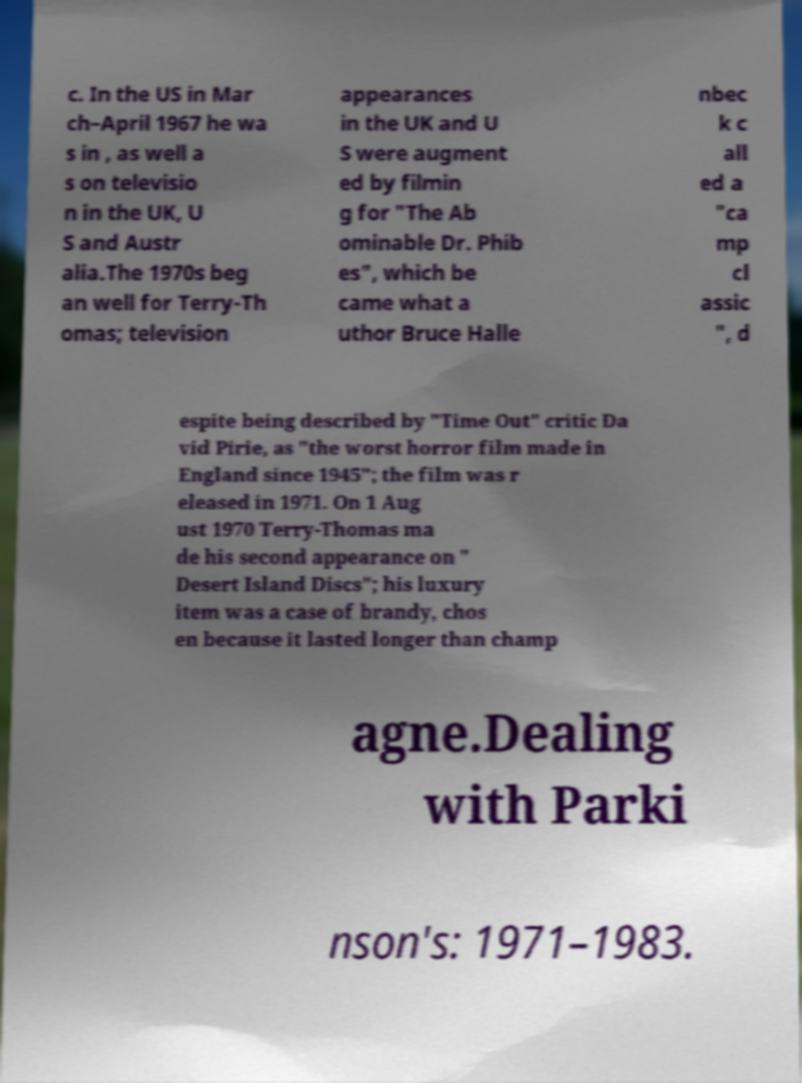Can you read and provide the text displayed in the image?This photo seems to have some interesting text. Can you extract and type it out for me? c. In the US in Mar ch–April 1967 he wa s in , as well a s on televisio n in the UK, U S and Austr alia.The 1970s beg an well for Terry-Th omas; television appearances in the UK and U S were augment ed by filmin g for "The Ab ominable Dr. Phib es", which be came what a uthor Bruce Halle nbec k c all ed a "ca mp cl assic ", d espite being described by "Time Out" critic Da vid Pirie, as "the worst horror film made in England since 1945"; the film was r eleased in 1971. On 1 Aug ust 1970 Terry-Thomas ma de his second appearance on " Desert Island Discs"; his luxury item was a case of brandy, chos en because it lasted longer than champ agne.Dealing with Parki nson's: 1971–1983. 